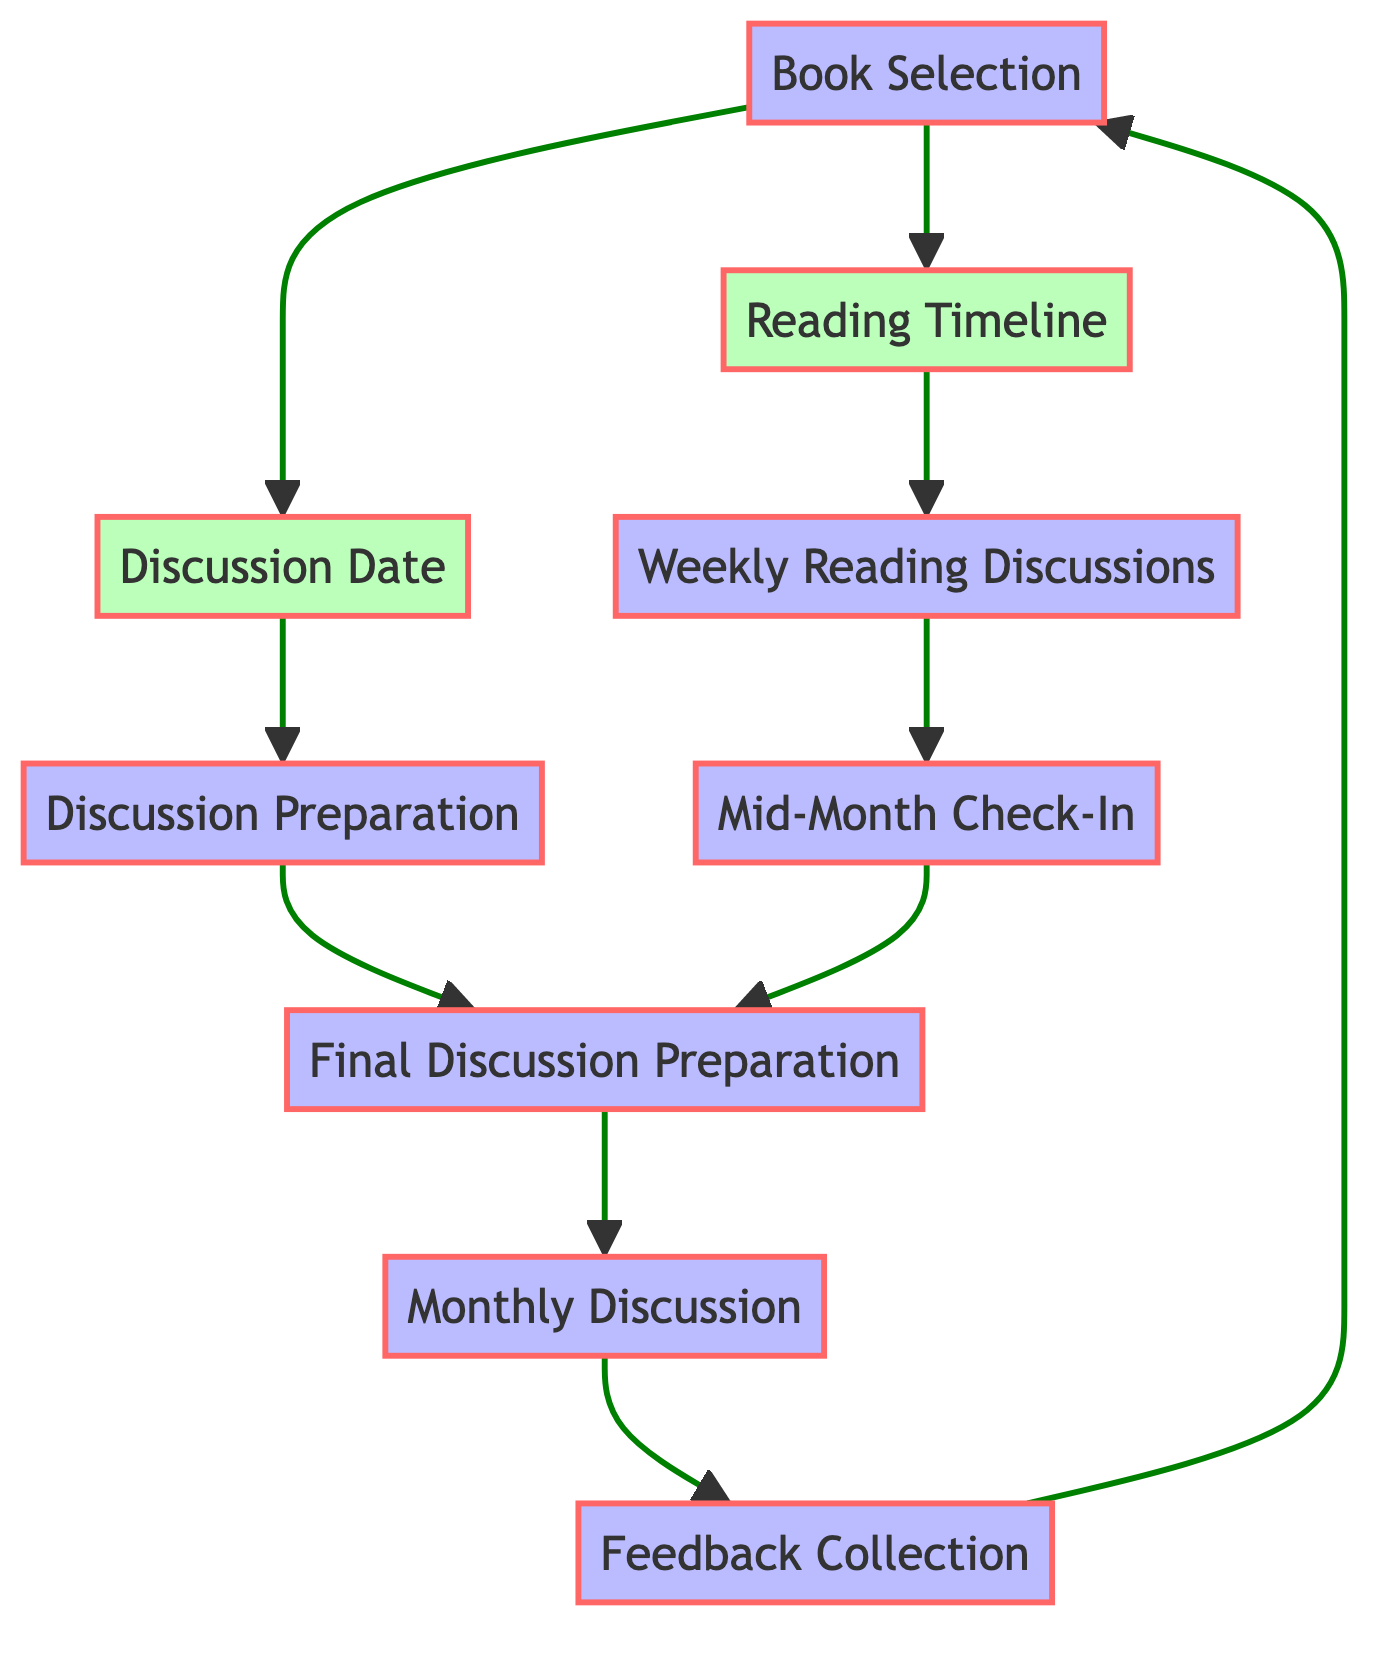What is the first component in the process? The diagram starts with the "Book Selection" component, which is the initial step in the monthly schedule.
Answer: Book Selection How many components are there in total? The diagram includes eight components, each representing a step in the reading and discussion process.
Answer: Eight What outcome does the "Reading Timeline" lead to? The "Reading Timeline" directly leads to "Weekly Reading Discussions," which is the next step in the flow.
Answer: Weekly Reading Discussions Which components are responsible for preparation? Both "Discussion Preparation" and "Final Discussion Preparation" are designated as preparation steps in the process.
Answer: Discussion Preparation, Final Discussion Preparation What occurs after the "Mid-Month Check-In"? After the "Mid-Month Check-In," the flow continues to "Final Discussion Preparation," indicating the process of preparing for the final discussion.
Answer: Final Discussion Preparation How does the feedback loop initiate in the diagram? The feedback loop starts from "Feedback Collection," which connects back to "Book Selection," indicating that feedback can influence future book selections.
Answer: Book Selection What is the outcome of the "Monthly Discussion"? The "Monthly Discussion" leads to "Feedback Collection," which is the subsequent component in the flow.
Answer: Feedback Collection How many virtual meetings are planned according to the timeline? According to the "Weekly Reading Discussions," there are likely four virtual meetings planned, one for each of the weekly segments leading up to the monthly discussion.
Answer: Four What is a shared outcome of both "Discussion Date" and "Reading Timeline"? Both the "Discussion Date" and "Reading Timeline" outcomes contribute to "Discussion Preparation," which merges the preparations from both steps.
Answer: Discussion Preparation 